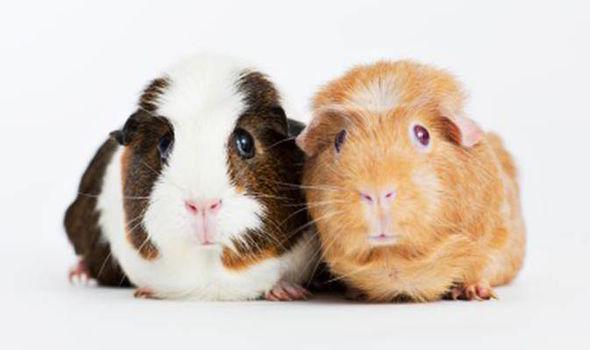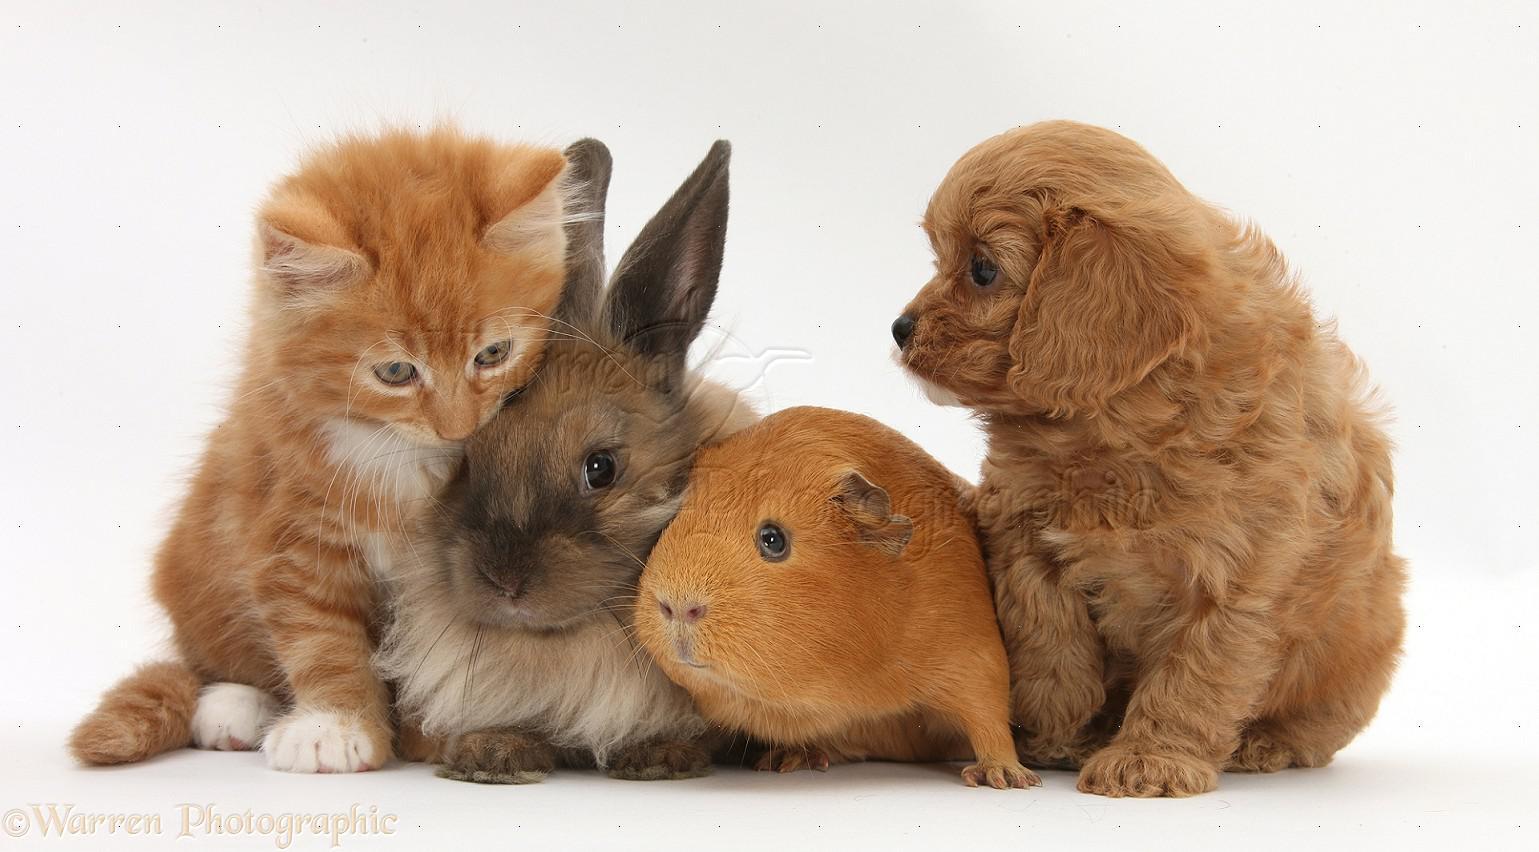The first image is the image on the left, the second image is the image on the right. For the images displayed, is the sentence "In the left image, there are two guinea pigs" factually correct? Answer yes or no. Yes. 